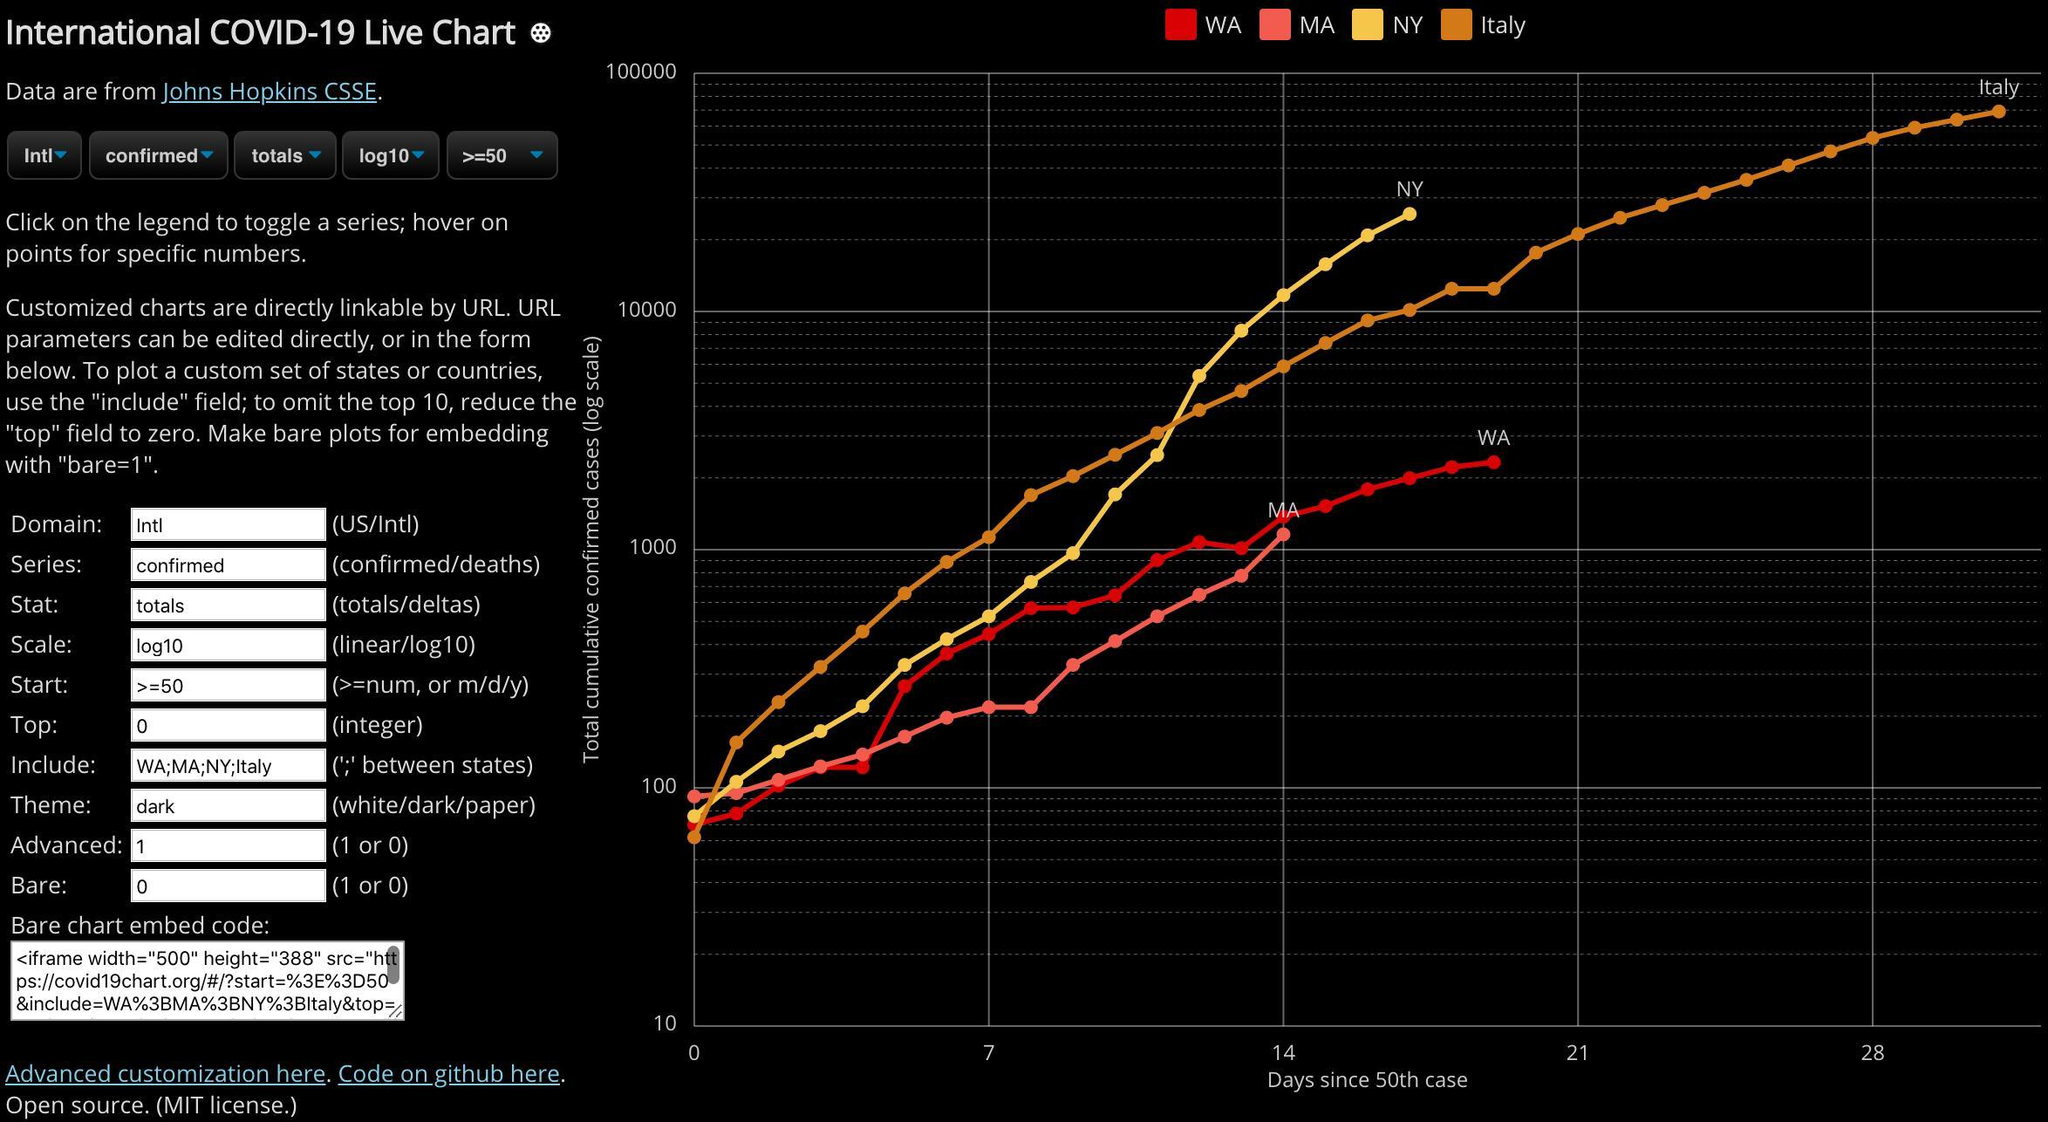Which city is represented in red?
Answer the question with a short phrase. WA Which cities have not crossed Day 21, since the 50th case reported? NY, WA, MA Which city has the lowest 'total cumulative confirmed cases' on Day zero? MA Which city has the second lowest 'total cumulative confirmed cases', as on day 14? WA Which country has crossed 28 days since the 50th case? Italy What are the available options for the 'theme' field ? White/dark/paper Which is the punctuation mark used in the 'Include' field of the form? ; Which two fields have the value 0, in the form? Top, Bare What are the available options for the 'Series' field ? confirmed/deaths How many regions are compared on the plot? 4 Which is the second field in the form? Series Which country has the second highest 'total cumulative confirmed cases' as on day 14? Italy Which city has the highest 'total cumulative confirmed cases', on Day 14? NY What are the available options for Domain field? US/Intl Which is the third field in the form? Stat 